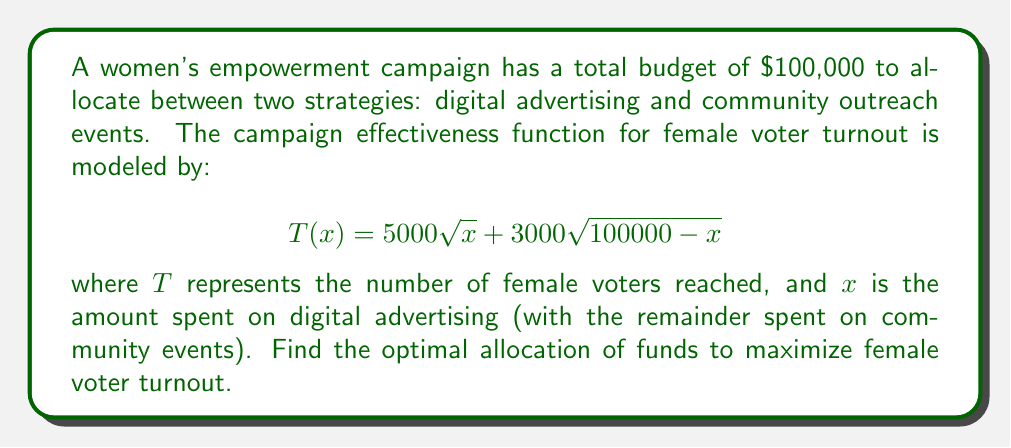Teach me how to tackle this problem. To find the optimal allocation, we need to maximize the function $T(x)$. We can do this by finding where the derivative of $T(x)$ equals zero.

1) First, let's calculate the derivative of $T(x)$:

   $$T'(x) = \frac{2500}{\sqrt{x}} - \frac{1500}{\sqrt{100000-x}}$$

2) Set $T'(x) = 0$ and solve for $x$:

   $$\frac{2500}{\sqrt{x}} = \frac{1500}{\sqrt{100000-x}}$$

3) Square both sides:

   $$\frac{6250000}{x} = \frac{2250000}{100000-x}$$

4) Cross multiply:

   $$625000000 - 6250000x = 2250000x$$

5) Solve for $x$:

   $$625000000 = 8500000x$$
   $$x = \frac{625000000}{8500000} \approx 73529.41$$

6) To confirm this is a maximum, we can check the second derivative:

   $$T''(x) = -\frac{1250}{x^{3/2}} - \frac{750}{(100000-x)^{3/2}}$$

   This is always negative, confirming we have found a maximum.

7) Therefore, the optimal allocation is approximately $73,529 for digital advertising and $26,471 for community events.
Answer: The optimal allocation is approximately $73,529 for digital advertising and $26,471 for community events, maximizing female voter turnout. 